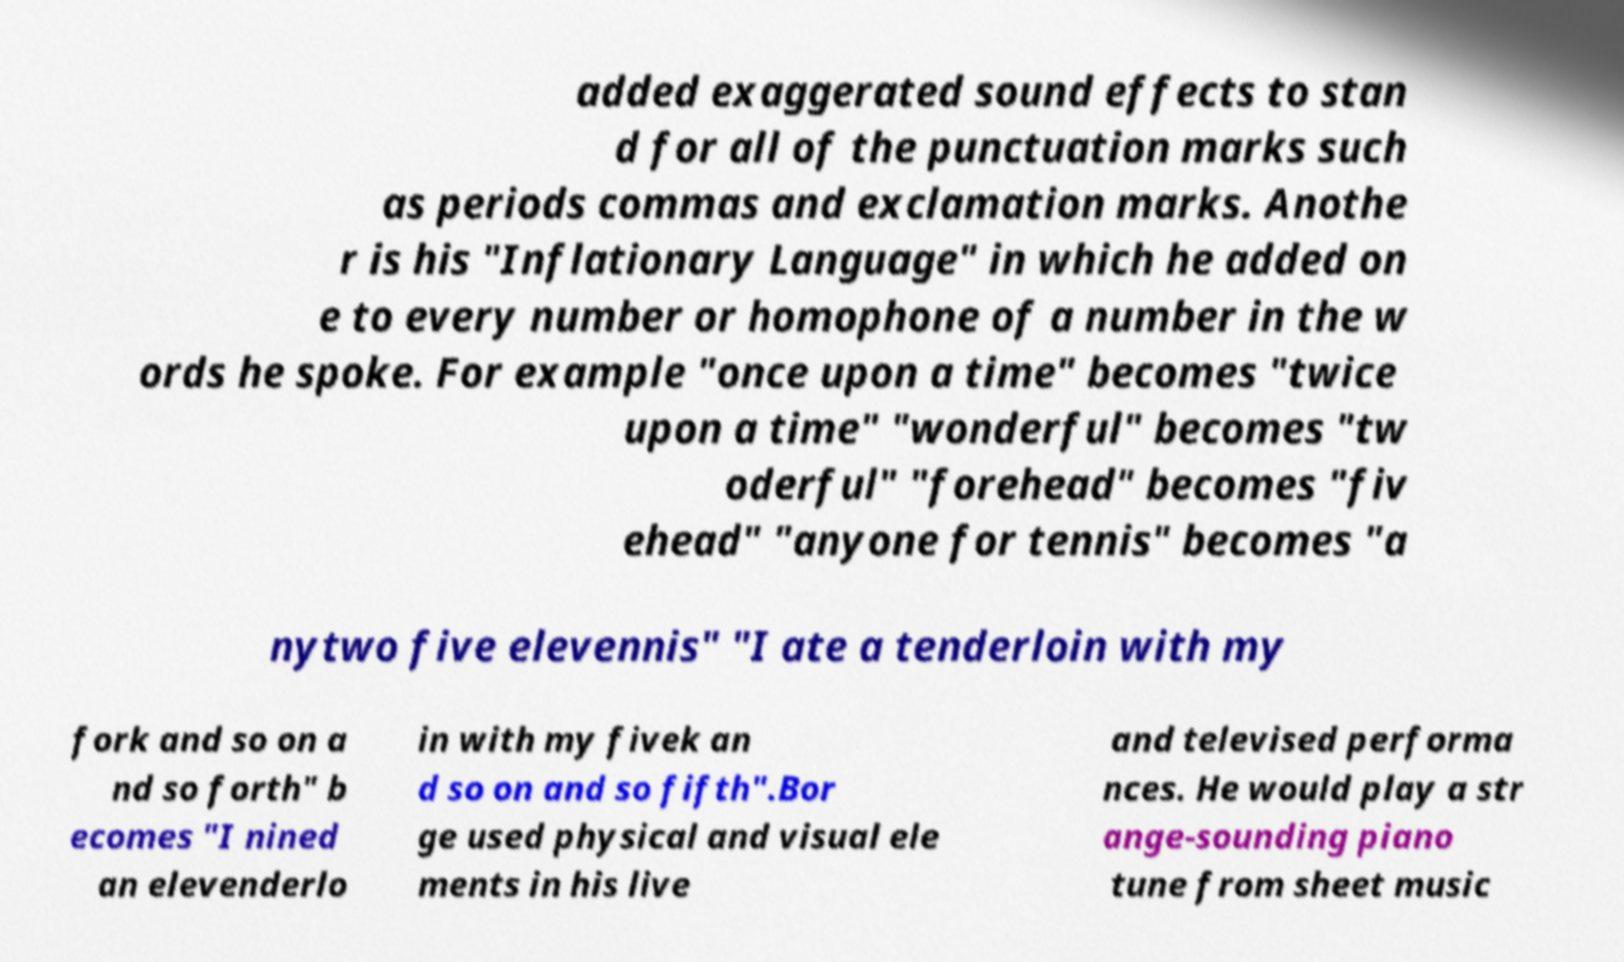Can you read and provide the text displayed in the image?This photo seems to have some interesting text. Can you extract and type it out for me? added exaggerated sound effects to stan d for all of the punctuation marks such as periods commas and exclamation marks. Anothe r is his "Inflationary Language" in which he added on e to every number or homophone of a number in the w ords he spoke. For example "once upon a time" becomes "twice upon a time" "wonderful" becomes "tw oderful" "forehead" becomes "fiv ehead" "anyone for tennis" becomes "a nytwo five elevennis" "I ate a tenderloin with my fork and so on a nd so forth" b ecomes "I nined an elevenderlo in with my fivek an d so on and so fifth".Bor ge used physical and visual ele ments in his live and televised performa nces. He would play a str ange-sounding piano tune from sheet music 